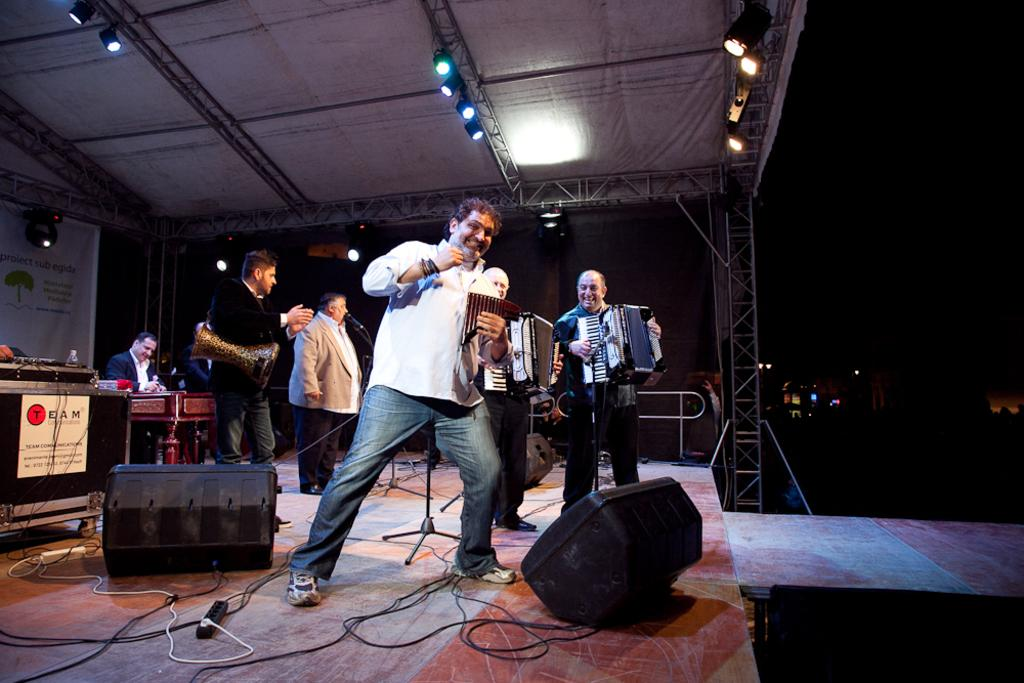What are the people on the stage doing? The people on the stage are performing. What are the performers using during their performance? The performers are using musical instruments. Can you describe the structure on top of the stage? There is a shed on top of the stage. What type of illumination is present in the image? There is lighting present. What type of dress is the maid wearing in the image? There is no maid or dress present in the image. What discovery was made during the performance? The image does not depict any specific discovery made during the performance. 